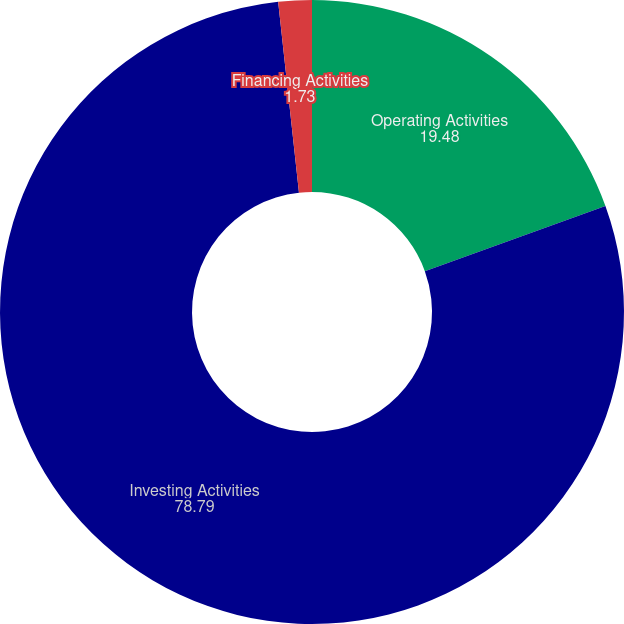Convert chart to OTSL. <chart><loc_0><loc_0><loc_500><loc_500><pie_chart><fcel>Operating Activities<fcel>Investing Activities<fcel>Financing Activities<nl><fcel>19.48%<fcel>78.79%<fcel>1.73%<nl></chart> 